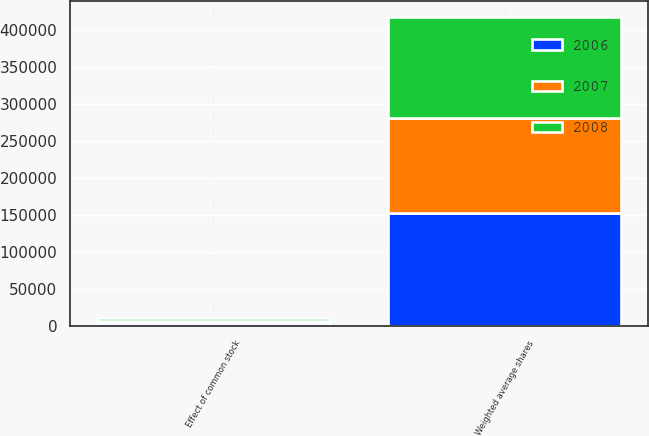Convert chart. <chart><loc_0><loc_0><loc_500><loc_500><stacked_bar_chart><ecel><fcel>Weighted average shares<fcel>Effect of common stock<nl><fcel>2007<fcel>128533<fcel>3117<nl><fcel>2008<fcel>137639<fcel>3305<nl><fcel>2006<fcel>152317<fcel>3736<nl></chart> 